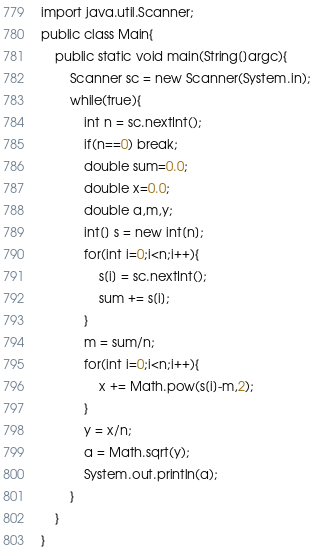Convert code to text. <code><loc_0><loc_0><loc_500><loc_500><_Java_>import java.util.Scanner;
public class Main{
    public static void main(String[]argc){
        Scanner sc = new Scanner(System.in);
        while(true){
            int n = sc.nextInt();
            if(n==0) break; 
            double sum=0.0;
            double x=0.0;
            double a,m,y;
            int[] s = new int[n];
            for(int i=0;i<n;i++){
                s[i] = sc.nextInt();
                sum += s[i];
            }
            m = sum/n;
            for(int i=0;i<n;i++){
                x += Math.pow(s[i]-m,2);
            }
            y = x/n;
            a = Math.sqrt(y);
            System.out.println(a);
        }
    }
}
</code> 